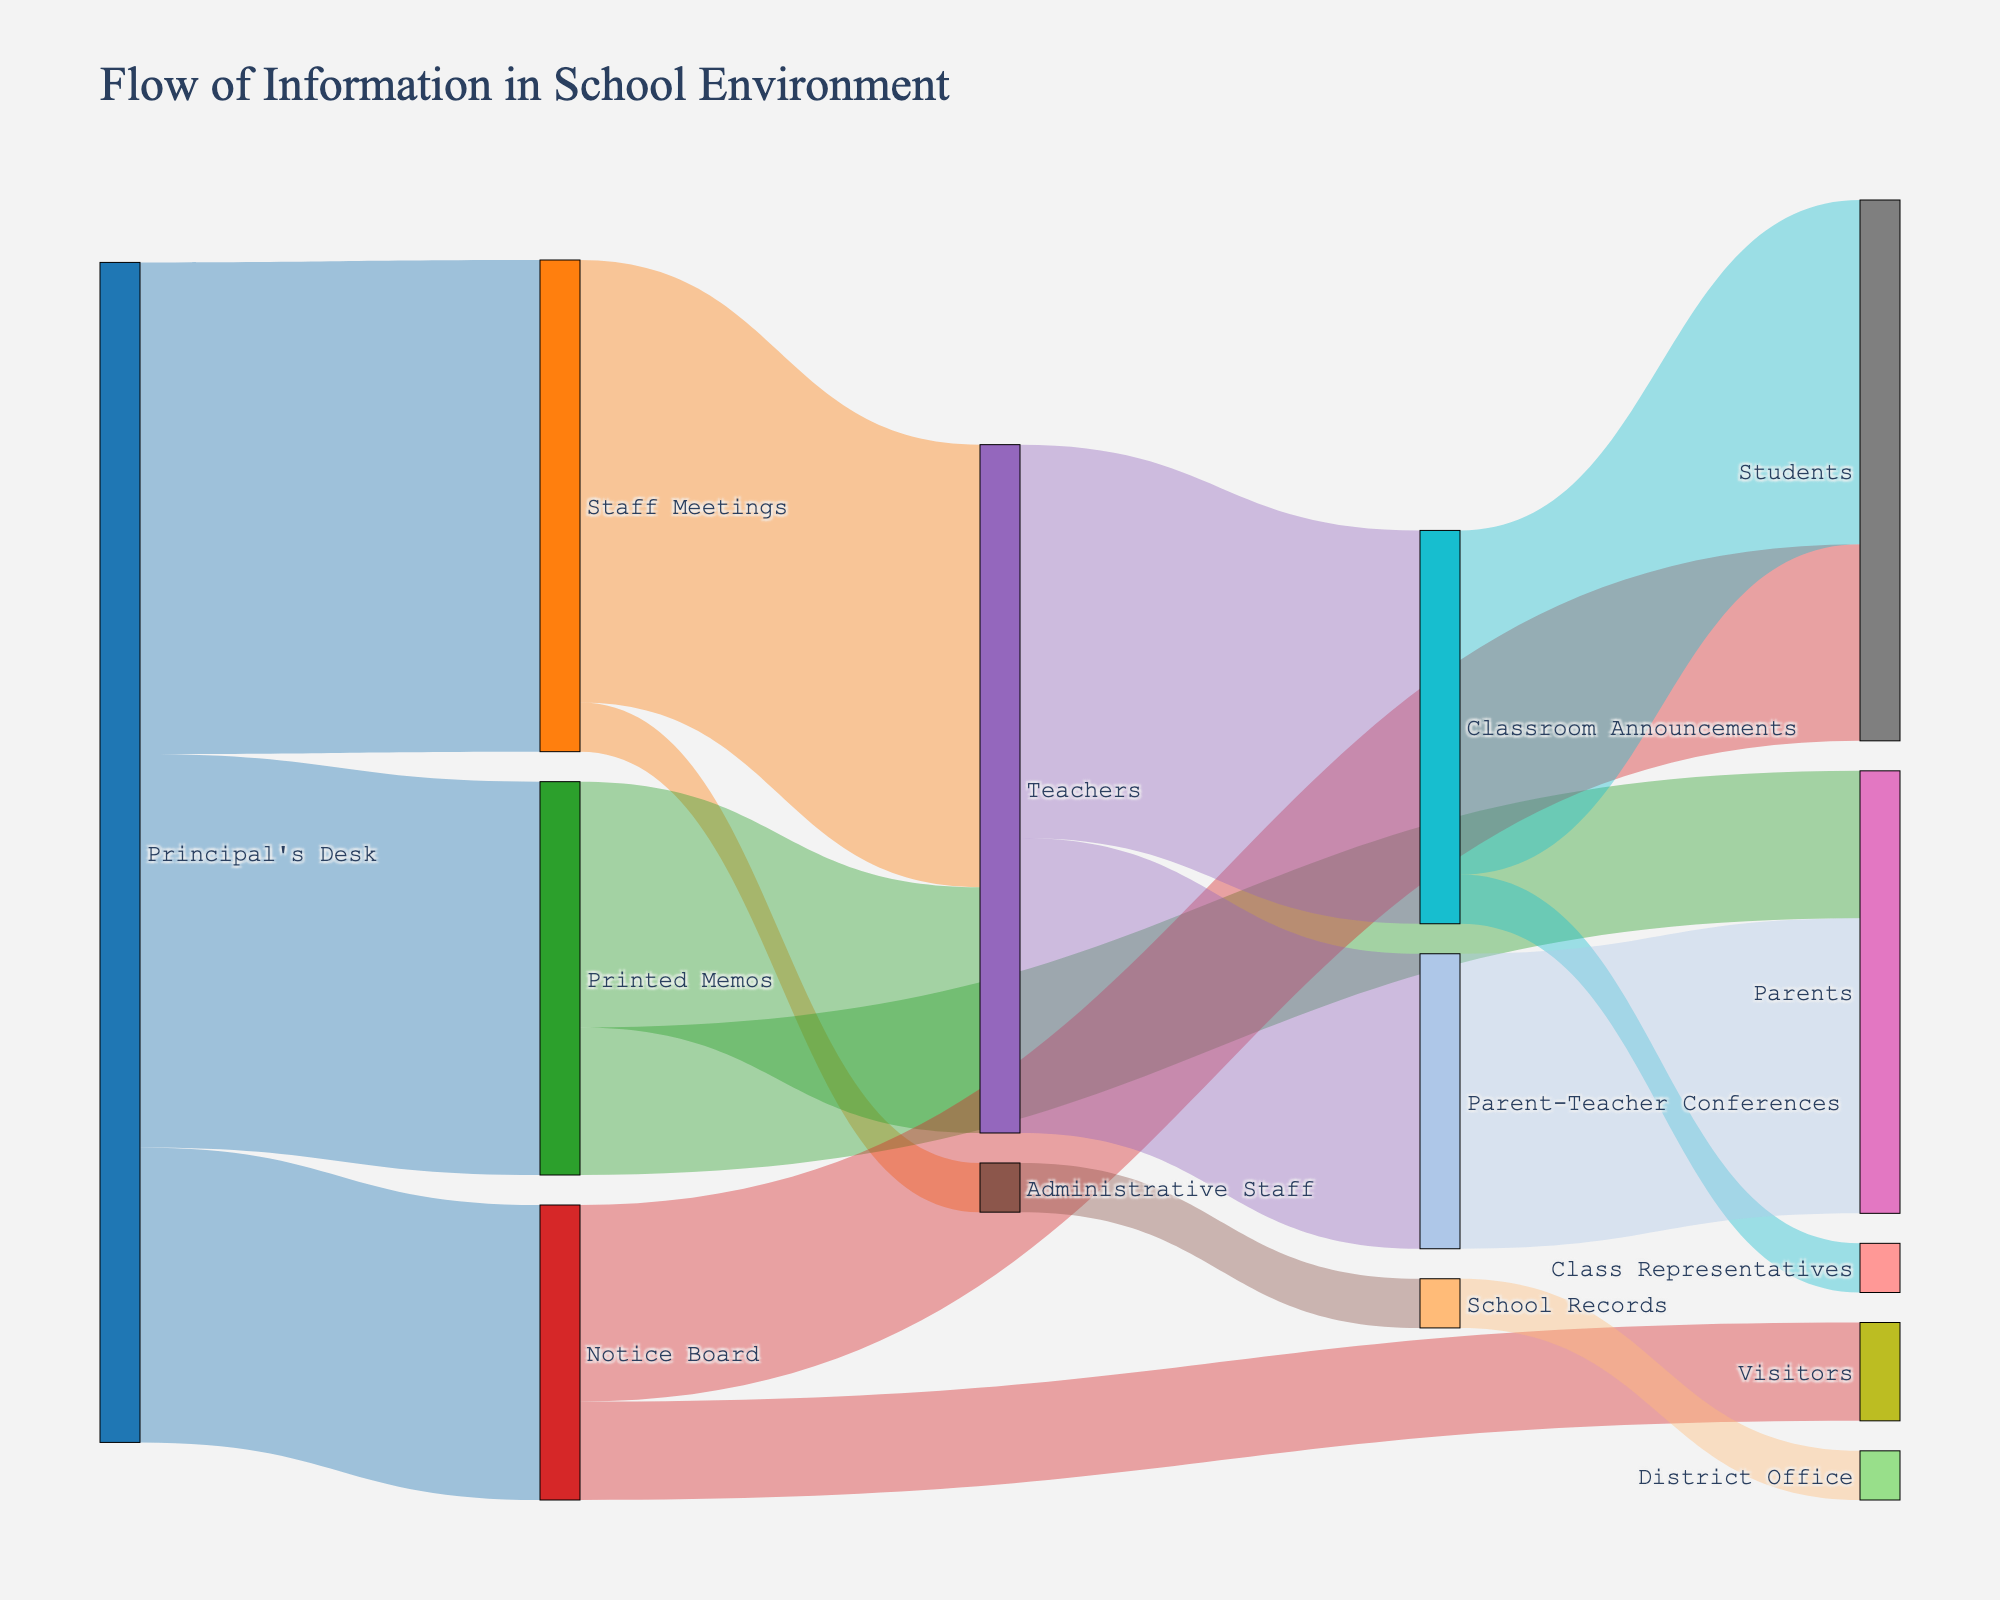What is the main source of information flow shown in the diagram? The largest and most centrally positioned node in the diagram represents "Principal's Desk," indicating that it is the main source of information flow.
Answer: Principal's Desk How many different channels receive information directly from the Principal's Desk? By visually inspecting the Sankey diagram, we see three channels (Staff Meetings, Printed Memos, and Notice Board) directly receiving information from the Principal's Desk.
Answer: 3 What is the total value of information flowing from the Principal's Desk? Add up the values of the outflows from the Principal's Desk: 50 (Staff Meetings) + 40 (Printed Memos) + 30 (Notice Board) = 120.
Answer: 120 Which channel receives the least information from the Principal's Desk? By comparing the values of the outflows from the Principal's Desk, the Notice Board, with a value of 30, receives the least information.
Answer: Notice Board Which node is the direct target of information from both the Staff Meetings and Printed Memos? Teachers node receives information flows from both Staff Meetings (45) and Printed Memos (25).
Answer: Teachers What is the total value of information received by the Students? By adding the values of flows to Students from Notice Board (20) and Classroom Announcements (35): 20 + 35 = 55.
Answer: 55 If we consider only the information flow from Principal's Desk to Staff Meetings and then to Teachers, what is the total value of this path? The value from Principal's Desk to Staff Meetings is 50, and from Staff Meetings to Teachers is 45. Thus, the total value for this path is the minimum of these two values, which is 45.
Answer: 45 Which source sends information to the widest variety of targets? By analyzing the node connections, Staff Meetings send information to the greatest variety of targets, including Teachers and Administrative Staff (2 different targets).
Answer: Staff Meetings Comparing the amount of information received by Parents from different channels, which channel has the higher value? By looking at the connections to Parents, Printed Memos (15) and Parent-Teacher Conferences (30). Parent-Teacher Conferences have a higher value.
Answer: Parent-Teacher Conferences 